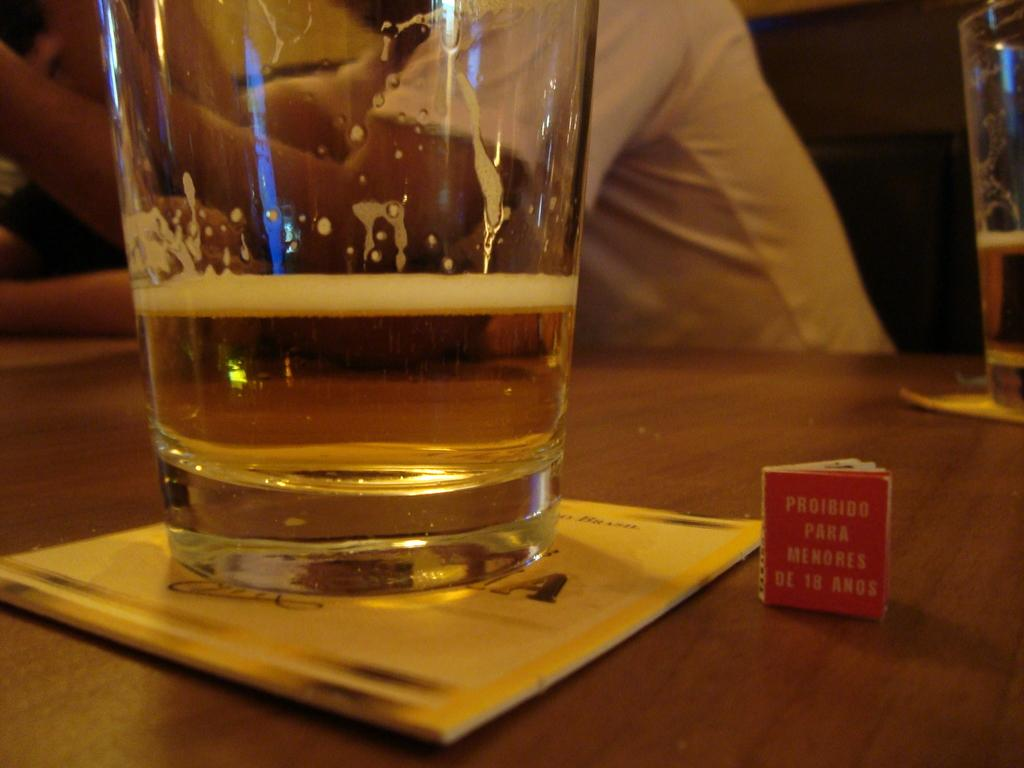Provide a one-sentence caption for the provided image. A small red tag with the last words reading de 18 anos. 